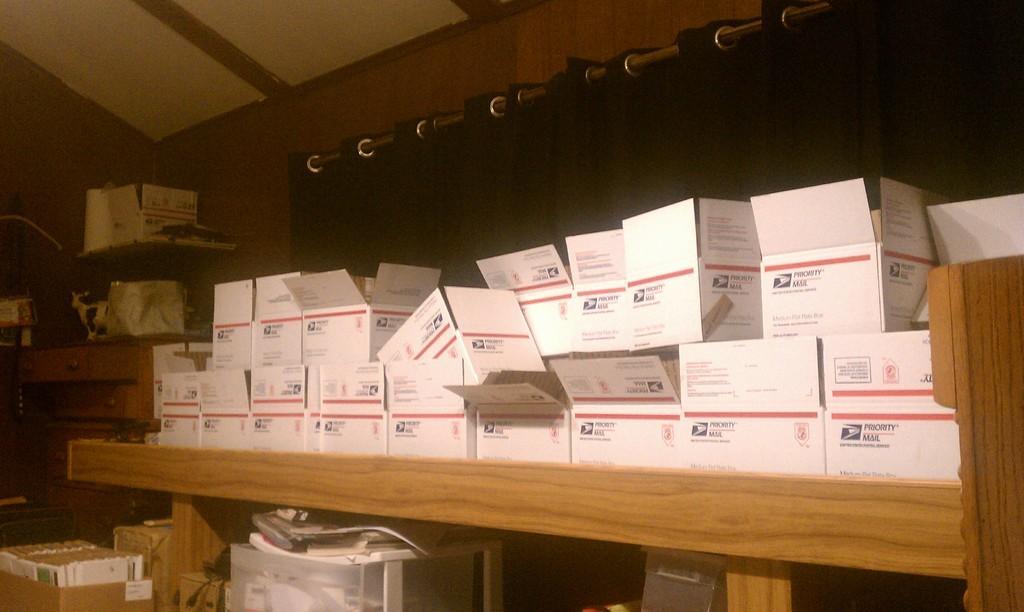How would you summarize this image in a sentence or two? In this picture we can see few boxes in the racks, in the background we can find a metal rod and curtain. 